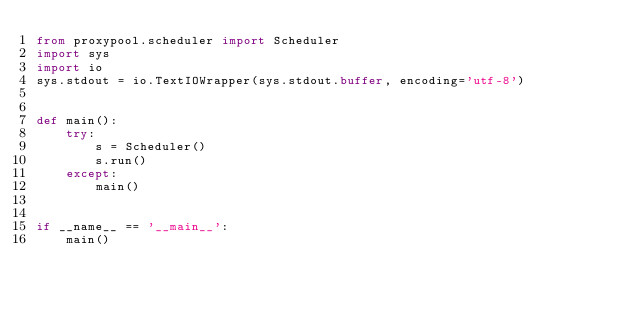<code> <loc_0><loc_0><loc_500><loc_500><_Python_>from proxypool.scheduler import Scheduler
import sys
import io
sys.stdout = io.TextIOWrapper(sys.stdout.buffer, encoding='utf-8')


def main():
    try:
        s = Scheduler()
        s.run()
    except:
        main()


if __name__ == '__main__':
    main()
</code> 